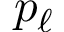Convert formula to latex. <formula><loc_0><loc_0><loc_500><loc_500>p _ { \ell }</formula> 